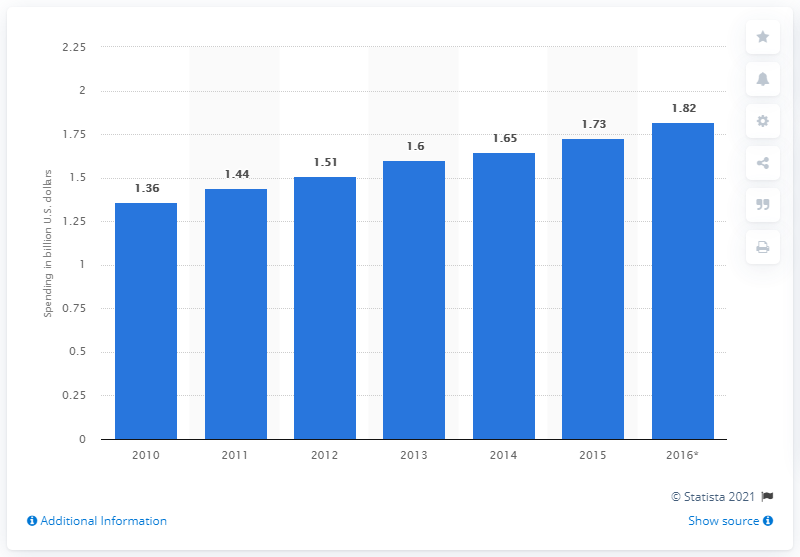Give some essential details in this illustration. In 2013, the global spending on golf sponsorships was approximately 1.6 billion U.S. dollars. 